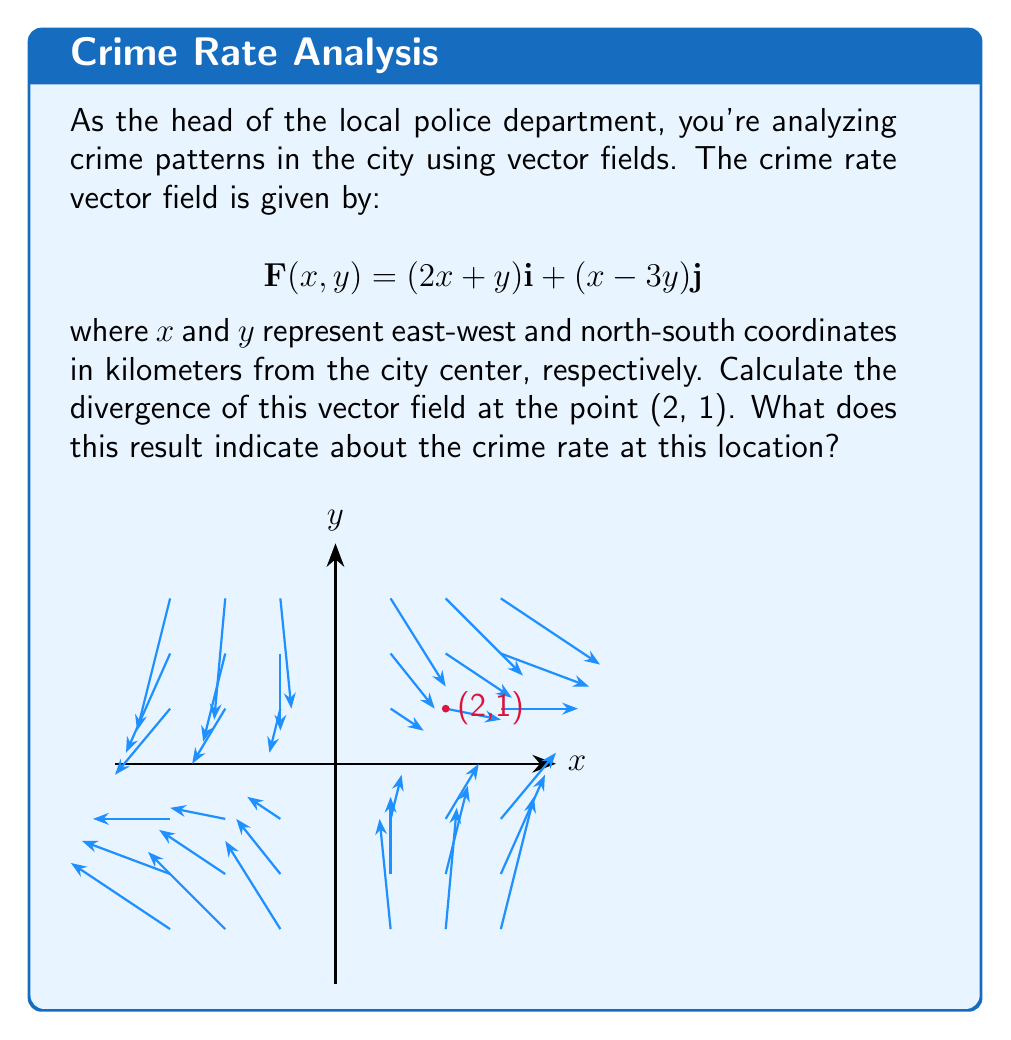What is the answer to this math problem? To solve this problem, we need to follow these steps:

1) The divergence of a vector field $\mathbf{F}(x,y) = P(x,y)\mathbf{i} + Q(x,y)\mathbf{j}$ is given by:

   $$\text{div}\mathbf{F} = \nabla \cdot \mathbf{F} = \frac{\partial P}{\partial x} + \frac{\partial Q}{\partial y}$$

2) In our case, $P(x,y) = 2x + y$ and $Q(x,y) = x - 3y$

3) Let's calculate the partial derivatives:
   
   $$\frac{\partial P}{\partial x} = \frac{\partial}{\partial x}(2x + y) = 2$$
   
   $$\frac{\partial Q}{\partial y} = \frac{\partial}{\partial y}(x - 3y) = -3$$

4) Now, we can calculate the divergence:

   $$\text{div}\mathbf{F} = \frac{\partial P}{\partial x} + \frac{\partial Q}{\partial y} = 2 + (-3) = -1$$

5) This result is constant and doesn't depend on $x$ and $y$, so it's the same at all points, including (2, 1).

6) Interpretation: The divergence represents the rate at which the vector field is expanding or contracting at a given point. A negative divergence (-1) indicates that the crime rate is decreasing (contracting) at this location. This suggests that the crime rate is lower in this area compared to its surroundings, possibly due to effective policing or other factors reducing criminal activity.
Answer: $-1$; indicates a decreasing crime rate at (2, 1) and surrounding areas. 